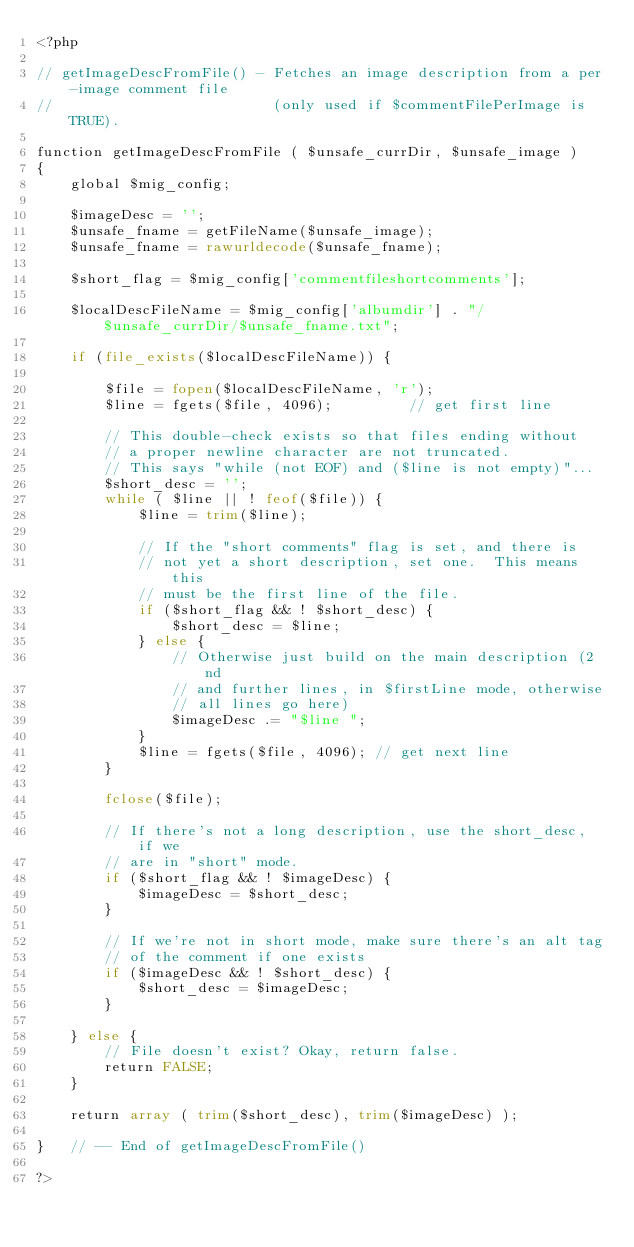Convert code to text. <code><loc_0><loc_0><loc_500><loc_500><_PHP_><?php

// getImageDescFromFile() - Fetches an image description from a per-image comment file
//                          (only used if $commentFilePerImage is TRUE).

function getImageDescFromFile ( $unsafe_currDir, $unsafe_image )
{
    global $mig_config;

    $imageDesc = '';
    $unsafe_fname = getFileName($unsafe_image);
    $unsafe_fname = rawurldecode($unsafe_fname);

    $short_flag = $mig_config['commentfileshortcomments'];

    $localDescFileName = $mig_config['albumdir'] . "/$unsafe_currDir/$unsafe_fname.txt";

    if (file_exists($localDescFileName)) {

        $file = fopen($localDescFileName, 'r');
        $line = fgets($file, 4096);         // get first line

        // This double-check exists so that files ending without
        // a proper newline character are not truncated.
        // This says "while (not EOF) and ($line is not empty)"...
        $short_desc = '';
        while ( $line || ! feof($file)) {
            $line = trim($line);

            // If the "short comments" flag is set, and there is
            // not yet a short description, set one.  This means this
            // must be the first line of the file.
            if ($short_flag && ! $short_desc) {
                $short_desc = $line;
            } else {
                // Otherwise just build on the main description (2nd
                // and further lines, in $firstLine mode, otherwise
                // all lines go here)
                $imageDesc .= "$line ";
            }
            $line = fgets($file, 4096); // get next line
        }

        fclose($file);

        // If there's not a long description, use the short_desc, if we
        // are in "short" mode.
        if ($short_flag && ! $imageDesc) {
            $imageDesc = $short_desc;
        }

        // If we're not in short mode, make sure there's an alt tag
        // of the comment if one exists
        if ($imageDesc && ! $short_desc) {
            $short_desc = $imageDesc;
        }

    } else {
        // File doesn't exist? Okay, return false.
        return FALSE;
    }

    return array ( trim($short_desc), trim($imageDesc) );

}   // -- End of getImageDescFromFile()

?>
</code> 